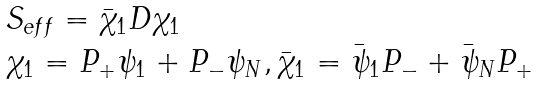<formula> <loc_0><loc_0><loc_500><loc_500>\begin{array} { l } S _ { e f f } = \bar { \chi } _ { 1 } D \chi _ { 1 } \\ \chi _ { 1 } = P _ { + } \psi _ { 1 } + P _ { - } \psi _ { N } , \bar { \chi } _ { 1 } = \bar { \psi } _ { 1 } P _ { - } + \bar { \psi } _ { N } P _ { + } \end{array}</formula> 